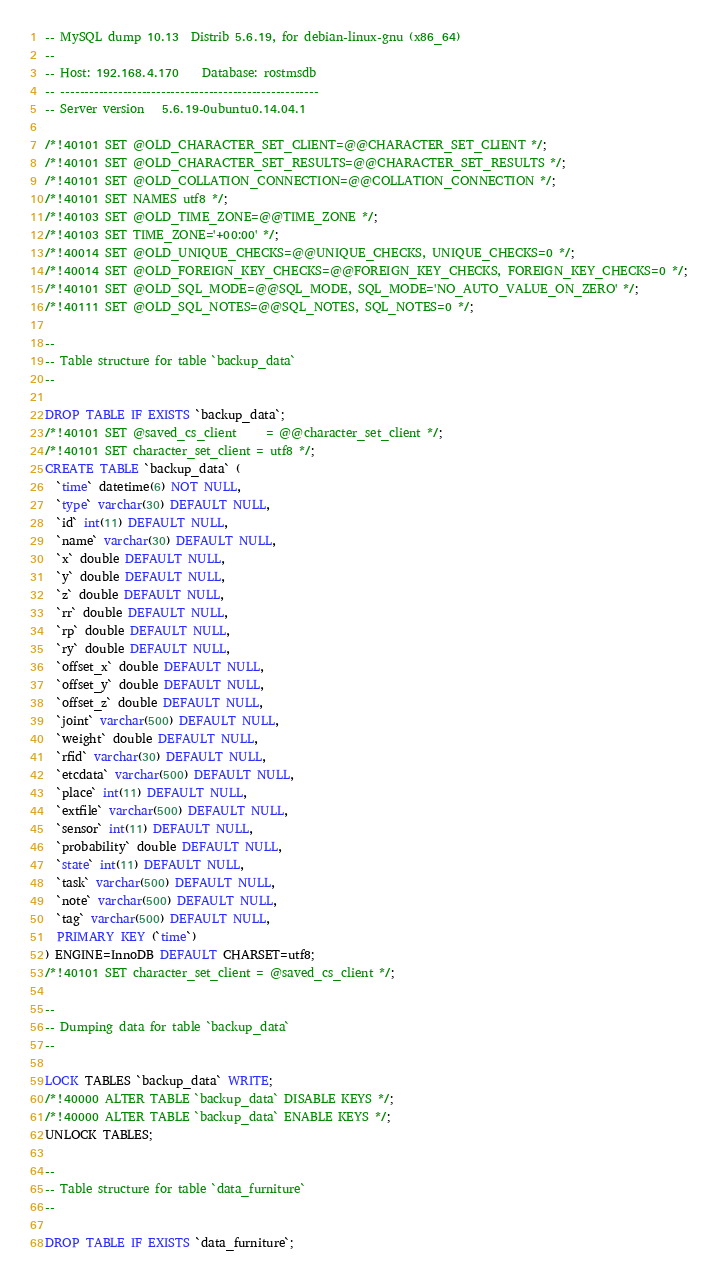Convert code to text. <code><loc_0><loc_0><loc_500><loc_500><_SQL_>-- MySQL dump 10.13  Distrib 5.6.19, for debian-linux-gnu (x86_64)
--
-- Host: 192.168.4.170    Database: rostmsdb
-- ------------------------------------------------------
-- Server version	5.6.19-0ubuntu0.14.04.1

/*!40101 SET @OLD_CHARACTER_SET_CLIENT=@@CHARACTER_SET_CLIENT */;
/*!40101 SET @OLD_CHARACTER_SET_RESULTS=@@CHARACTER_SET_RESULTS */;
/*!40101 SET @OLD_COLLATION_CONNECTION=@@COLLATION_CONNECTION */;
/*!40101 SET NAMES utf8 */;
/*!40103 SET @OLD_TIME_ZONE=@@TIME_ZONE */;
/*!40103 SET TIME_ZONE='+00:00' */;
/*!40014 SET @OLD_UNIQUE_CHECKS=@@UNIQUE_CHECKS, UNIQUE_CHECKS=0 */;
/*!40014 SET @OLD_FOREIGN_KEY_CHECKS=@@FOREIGN_KEY_CHECKS, FOREIGN_KEY_CHECKS=0 */;
/*!40101 SET @OLD_SQL_MODE=@@SQL_MODE, SQL_MODE='NO_AUTO_VALUE_ON_ZERO' */;
/*!40111 SET @OLD_SQL_NOTES=@@SQL_NOTES, SQL_NOTES=0 */;

--
-- Table structure for table `backup_data`
--

DROP TABLE IF EXISTS `backup_data`;
/*!40101 SET @saved_cs_client     = @@character_set_client */;
/*!40101 SET character_set_client = utf8 */;
CREATE TABLE `backup_data` (
  `time` datetime(6) NOT NULL,
  `type` varchar(30) DEFAULT NULL,
  `id` int(11) DEFAULT NULL,
  `name` varchar(30) DEFAULT NULL,
  `x` double DEFAULT NULL,
  `y` double DEFAULT NULL,
  `z` double DEFAULT NULL,
  `rr` double DEFAULT NULL,
  `rp` double DEFAULT NULL,
  `ry` double DEFAULT NULL,
  `offset_x` double DEFAULT NULL,
  `offset_y` double DEFAULT NULL,
  `offset_z` double DEFAULT NULL,
  `joint` varchar(500) DEFAULT NULL,
  `weight` double DEFAULT NULL,
  `rfid` varchar(30) DEFAULT NULL,
  `etcdata` varchar(500) DEFAULT NULL,
  `place` int(11) DEFAULT NULL,
  `extfile` varchar(500) DEFAULT NULL,
  `sensor` int(11) DEFAULT NULL,
  `probability` double DEFAULT NULL,
  `state` int(11) DEFAULT NULL,
  `task` varchar(500) DEFAULT NULL,
  `note` varchar(500) DEFAULT NULL,
  `tag` varchar(500) DEFAULT NULL,
  PRIMARY KEY (`time`)
) ENGINE=InnoDB DEFAULT CHARSET=utf8;
/*!40101 SET character_set_client = @saved_cs_client */;

--
-- Dumping data for table `backup_data`
--

LOCK TABLES `backup_data` WRITE;
/*!40000 ALTER TABLE `backup_data` DISABLE KEYS */;
/*!40000 ALTER TABLE `backup_data` ENABLE KEYS */;
UNLOCK TABLES;

--
-- Table structure for table `data_furniture`
--

DROP TABLE IF EXISTS `data_furniture`;</code> 